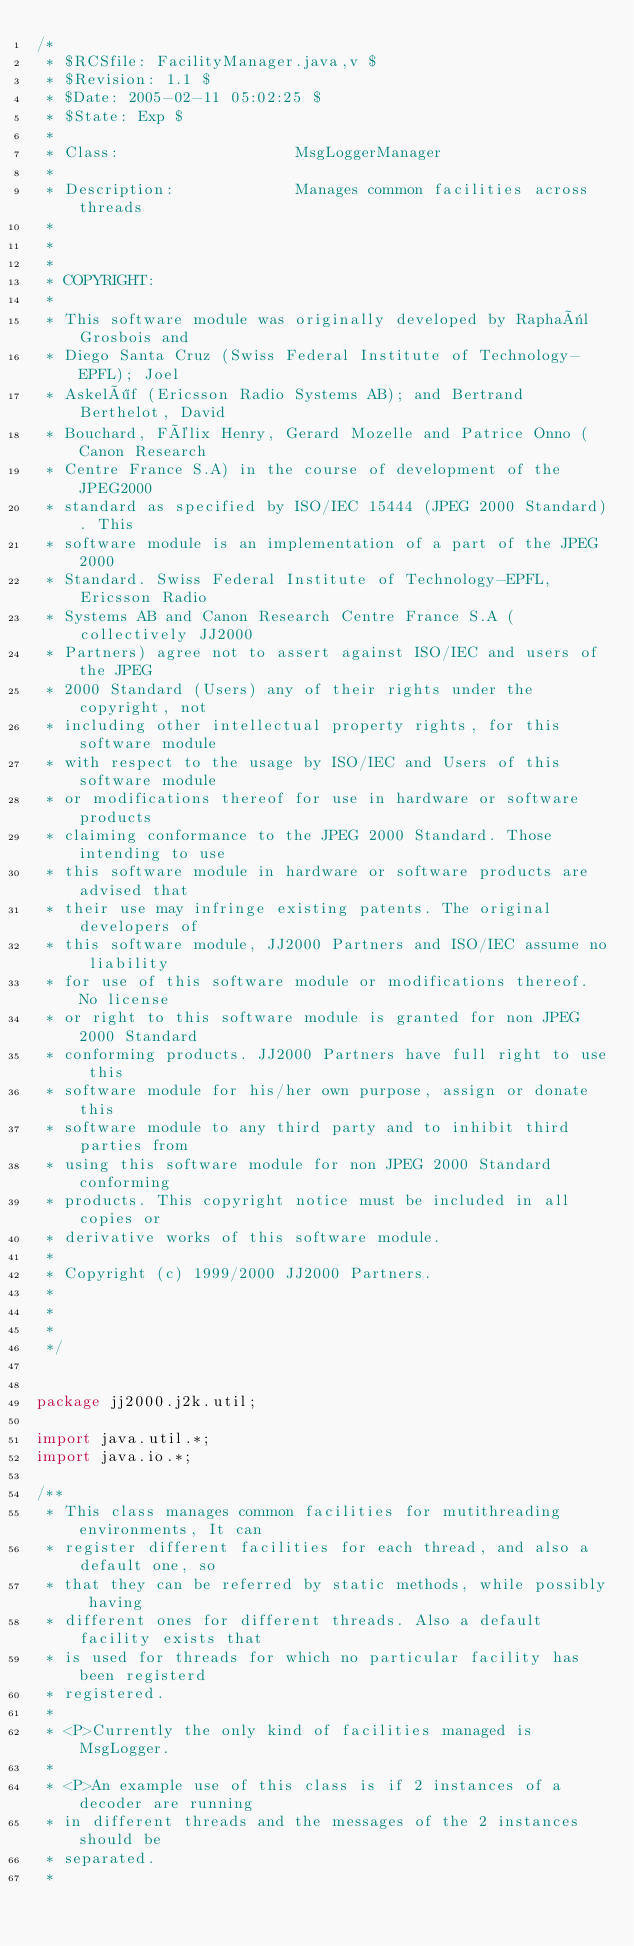<code> <loc_0><loc_0><loc_500><loc_500><_Java_>/*
 * $RCSfile: FacilityManager.java,v $
 * $Revision: 1.1 $
 * $Date: 2005-02-11 05:02:25 $
 * $State: Exp $
 *
 * Class:                   MsgLoggerManager
 *
 * Description:             Manages common facilities across threads
 *
 *
 *
 * COPYRIGHT:
 *
 * This software module was originally developed by Raphaël Grosbois and
 * Diego Santa Cruz (Swiss Federal Institute of Technology-EPFL); Joel
 * Askelöf (Ericsson Radio Systems AB); and Bertrand Berthelot, David
 * Bouchard, Félix Henry, Gerard Mozelle and Patrice Onno (Canon Research
 * Centre France S.A) in the course of development of the JPEG2000
 * standard as specified by ISO/IEC 15444 (JPEG 2000 Standard). This
 * software module is an implementation of a part of the JPEG 2000
 * Standard. Swiss Federal Institute of Technology-EPFL, Ericsson Radio
 * Systems AB and Canon Research Centre France S.A (collectively JJ2000
 * Partners) agree not to assert against ISO/IEC and users of the JPEG
 * 2000 Standard (Users) any of their rights under the copyright, not
 * including other intellectual property rights, for this software module
 * with respect to the usage by ISO/IEC and Users of this software module
 * or modifications thereof for use in hardware or software products
 * claiming conformance to the JPEG 2000 Standard. Those intending to use
 * this software module in hardware or software products are advised that
 * their use may infringe existing patents. The original developers of
 * this software module, JJ2000 Partners and ISO/IEC assume no liability
 * for use of this software module or modifications thereof. No license
 * or right to this software module is granted for non JPEG 2000 Standard
 * conforming products. JJ2000 Partners have full right to use this
 * software module for his/her own purpose, assign or donate this
 * software module to any third party and to inhibit third parties from
 * using this software module for non JPEG 2000 Standard conforming
 * products. This copyright notice must be included in all copies or
 * derivative works of this software module.
 *
 * Copyright (c) 1999/2000 JJ2000 Partners.
 *
 *
 *
 */


package jj2000.j2k.util;

import java.util.*;
import java.io.*;

/**
 * This class manages common facilities for mutithreading environments, It can
 * register different facilities for each thread, and also a default one, so
 * that they can be referred by static methods, while possibly having
 * different ones for different threads. Also a default facility exists that
 * is used for threads for which no particular facility has been registerd
 * registered.
 *
 * <P>Currently the only kind of facilities managed is MsgLogger.
 *
 * <P>An example use of this class is if 2 instances of a decoder are running
 * in different threads and the messages of the 2 instances should be
 * separated.
 *</code> 